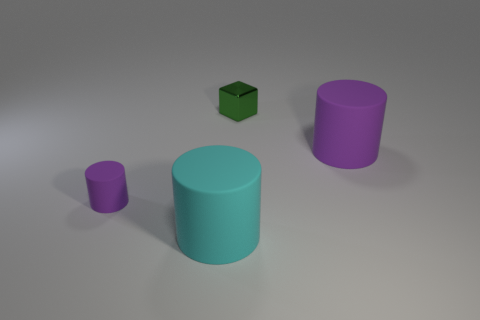Is there anything else that has the same material as the tiny green cube?
Provide a short and direct response. No. The big thing that is in front of the purple matte cylinder left of the purple rubber cylinder that is behind the small purple cylinder is what shape?
Provide a succinct answer. Cylinder. There is a big thing to the right of the large cyan object; is its shape the same as the big thing on the left side of the green metallic block?
Your answer should be very brief. Yes. Are there any big purple cylinders made of the same material as the big purple thing?
Make the answer very short. No. The matte object right of the cyan matte thing in front of the rubber cylinder left of the cyan object is what color?
Make the answer very short. Purple. Do the thing right of the tiny green shiny block and the thing that is behind the large purple cylinder have the same material?
Provide a succinct answer. No. The purple rubber object on the right side of the large cyan rubber object has what shape?
Your response must be concise. Cylinder. What number of things are tiny green cubes or cylinders on the left side of the metallic block?
Your answer should be very brief. 3. Are the tiny purple cylinder and the cyan thing made of the same material?
Ensure brevity in your answer.  Yes. Are there an equal number of tiny green objects that are in front of the tiny green cube and small purple matte cylinders on the right side of the big purple thing?
Offer a terse response. Yes. 